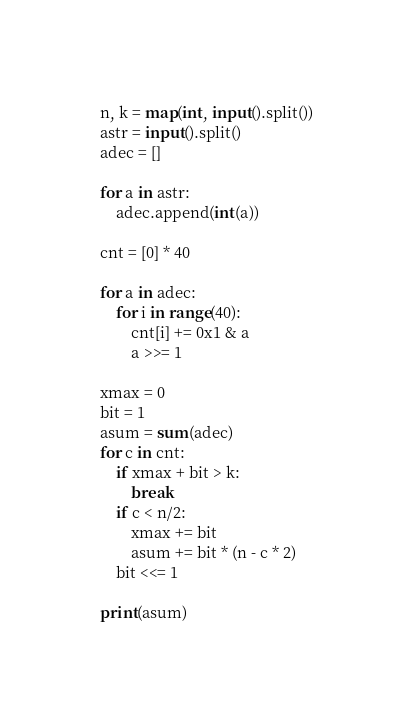<code> <loc_0><loc_0><loc_500><loc_500><_Python_>n, k = map(int, input().split())
astr = input().split()
adec = []

for a in astr:
    adec.append(int(a))

cnt = [0] * 40

for a in adec:
    for i in range(40):
        cnt[i] += 0x1 & a
        a >>= 1

xmax = 0
bit = 1
asum = sum(adec)
for c in cnt:
    if xmax + bit > k:
        break
    if c < n/2:
        xmax += bit
        asum += bit * (n - c * 2)
    bit <<= 1

print(asum)</code> 